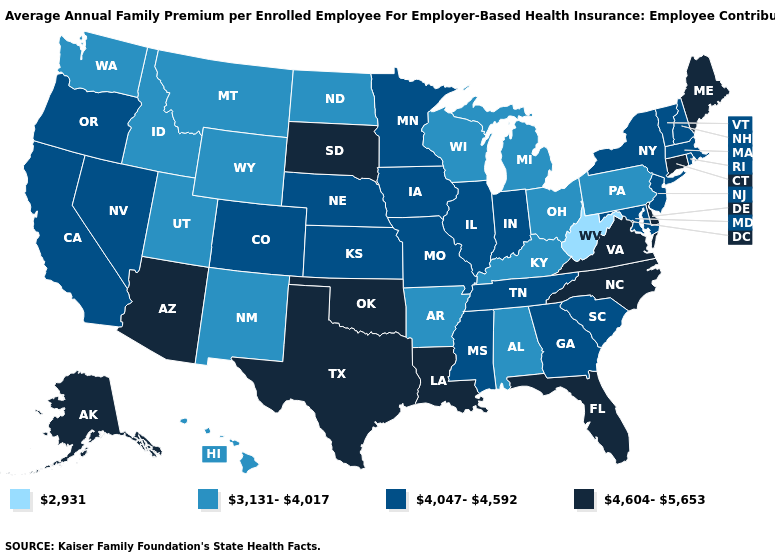What is the lowest value in the Northeast?
Keep it brief. 3,131-4,017. Name the states that have a value in the range 2,931?
Quick response, please. West Virginia. Name the states that have a value in the range 4,047-4,592?
Be succinct. California, Colorado, Georgia, Illinois, Indiana, Iowa, Kansas, Maryland, Massachusetts, Minnesota, Mississippi, Missouri, Nebraska, Nevada, New Hampshire, New Jersey, New York, Oregon, Rhode Island, South Carolina, Tennessee, Vermont. What is the value of Ohio?
Answer briefly. 3,131-4,017. Is the legend a continuous bar?
Answer briefly. No. Name the states that have a value in the range 2,931?
Write a very short answer. West Virginia. What is the highest value in states that border Maine?
Short answer required. 4,047-4,592. Name the states that have a value in the range 4,604-5,653?
Concise answer only. Alaska, Arizona, Connecticut, Delaware, Florida, Louisiana, Maine, North Carolina, Oklahoma, South Dakota, Texas, Virginia. What is the value of Maryland?
Keep it brief. 4,047-4,592. Name the states that have a value in the range 2,931?
Short answer required. West Virginia. What is the value of Oklahoma?
Give a very brief answer. 4,604-5,653. Name the states that have a value in the range 2,931?
Quick response, please. West Virginia. Does Wyoming have the highest value in the West?
Keep it brief. No. Does Colorado have a higher value than Oklahoma?
Keep it brief. No. What is the value of Florida?
Short answer required. 4,604-5,653. 